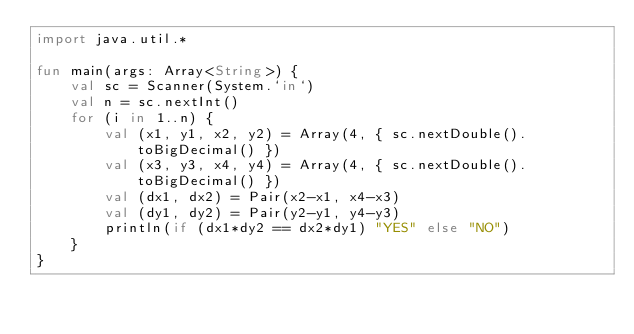<code> <loc_0><loc_0><loc_500><loc_500><_Kotlin_>import java.util.*

fun main(args: Array<String>) {
    val sc = Scanner(System.`in`)
    val n = sc.nextInt()
    for (i in 1..n) {
        val (x1, y1, x2, y2) = Array(4, { sc.nextDouble().toBigDecimal() })
        val (x3, y3, x4, y4) = Array(4, { sc.nextDouble().toBigDecimal() })
        val (dx1, dx2) = Pair(x2-x1, x4-x3)
        val (dy1, dy2) = Pair(y2-y1, y4-y3)
        println(if (dx1*dy2 == dx2*dy1) "YES" else "NO")
    }
}
</code> 